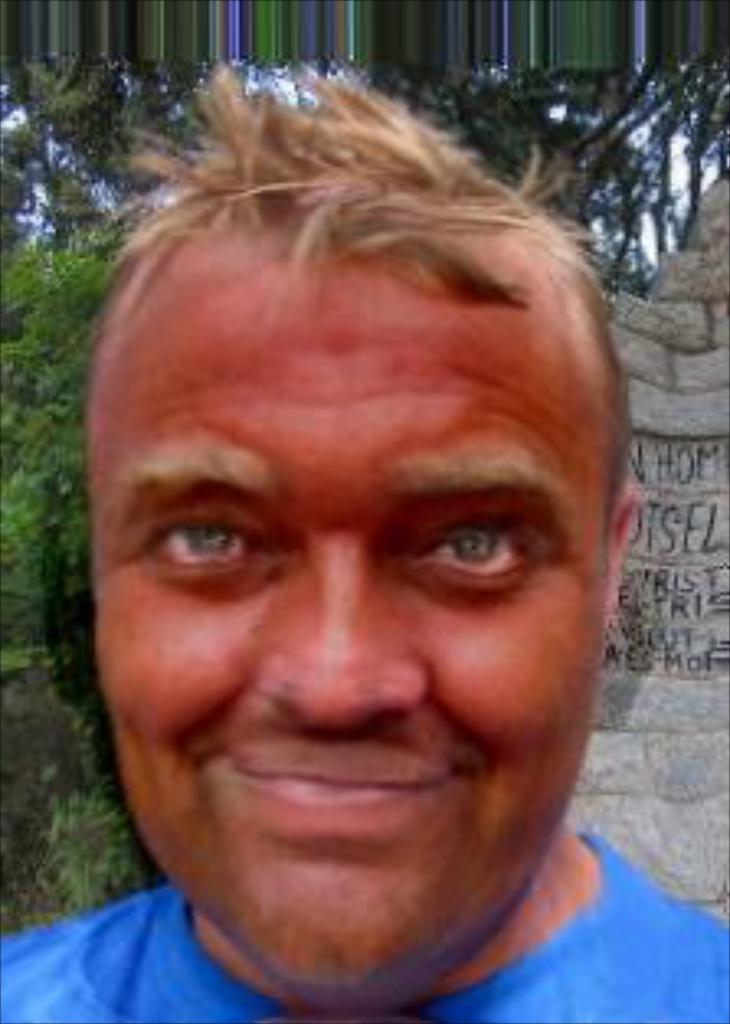Please provide a concise description of this image. In the middle of the image we can see a man, behind to him we can find few rocks and trees. 